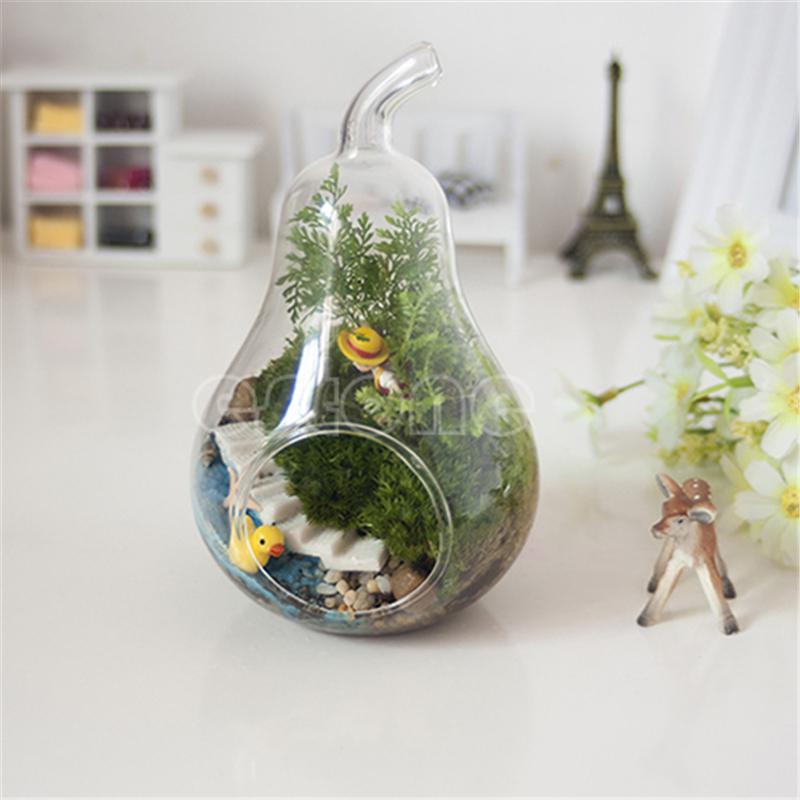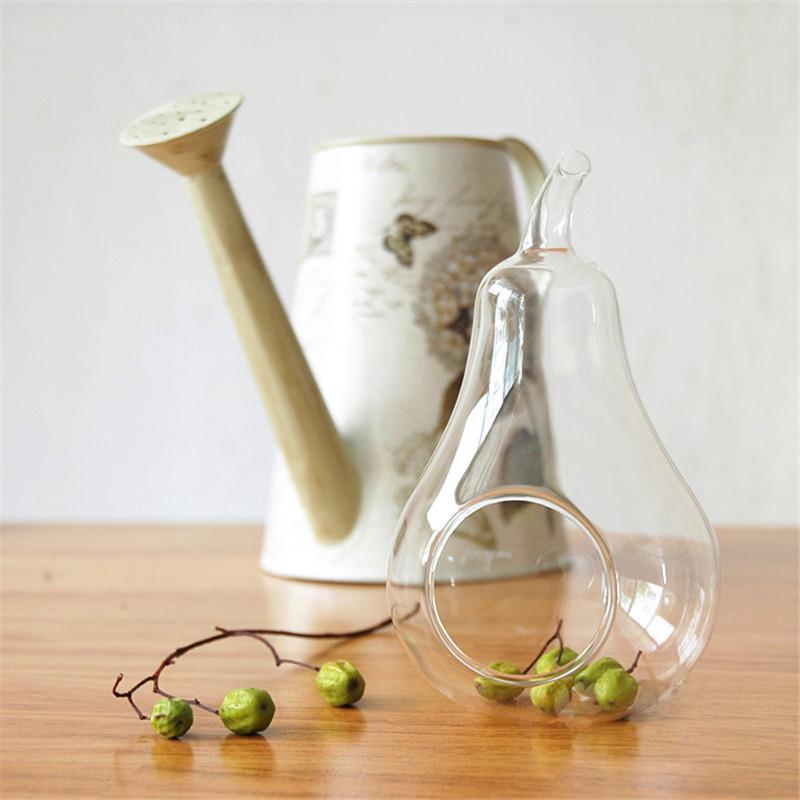The first image is the image on the left, the second image is the image on the right. Assess this claim about the two images: "Each image contains side-by-side terrariums in fruit shapes that rest on a surface, and the combined images include at least two pear shapes and one apple shape.". Correct or not? Answer yes or no. No. The first image is the image on the left, the second image is the image on the right. For the images displayed, is the sentence "A single terrarium shaped like a pear sits on a surface in the image on the left." factually correct? Answer yes or no. Yes. 